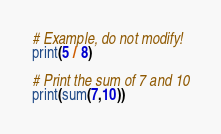<code> <loc_0><loc_0><loc_500><loc_500><_Python_># Example, do not modify!
print(5 / 8)

# Print the sum of 7 and 10
print(sum(7,10))</code> 